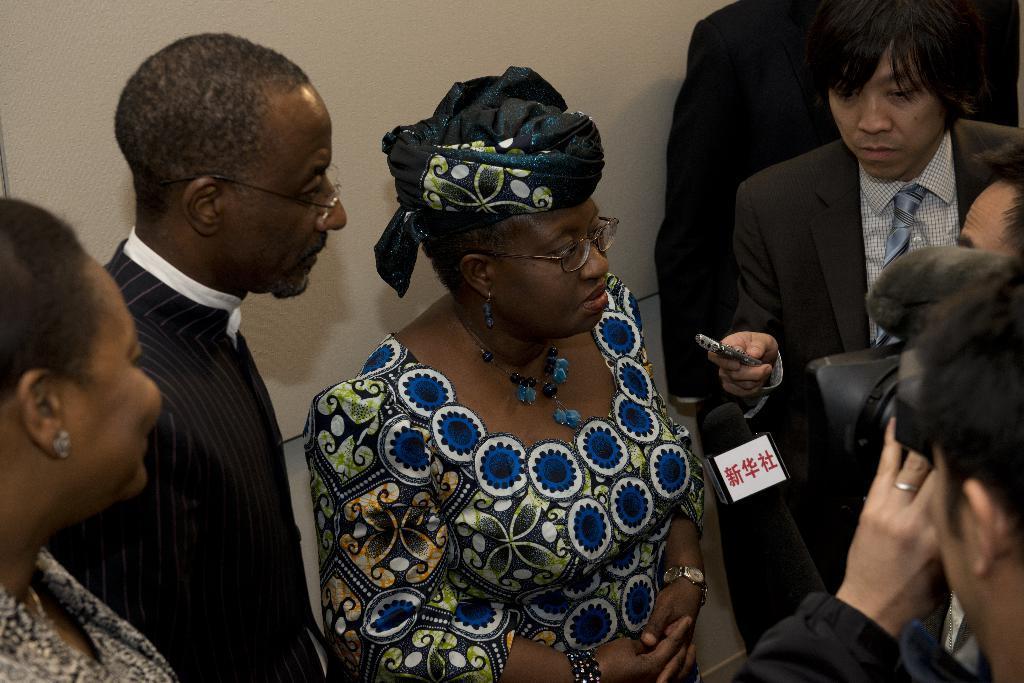Can you describe this image briefly? Here we can see few persons. There is a camera and a mike. In the background we can see a wall. 